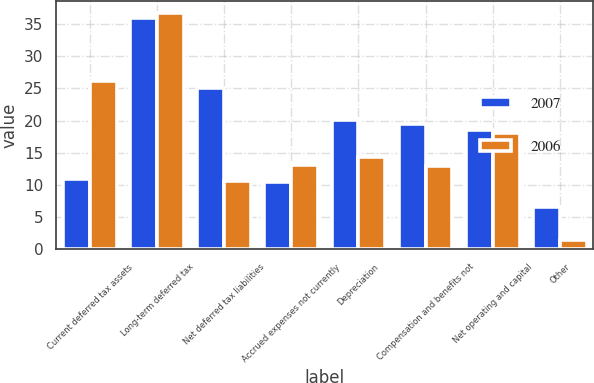<chart> <loc_0><loc_0><loc_500><loc_500><stacked_bar_chart><ecel><fcel>Current deferred tax assets<fcel>Long-term deferred tax<fcel>Net deferred tax liabilities<fcel>Accrued expenses not currently<fcel>Depreciation<fcel>Compensation and benefits not<fcel>Net operating and capital<fcel>Other<nl><fcel>2007<fcel>10.9<fcel>36<fcel>25.1<fcel>10.4<fcel>20.1<fcel>19.5<fcel>18.6<fcel>6.6<nl><fcel>2006<fcel>26.1<fcel>36.7<fcel>10.6<fcel>13.1<fcel>14.4<fcel>12.9<fcel>18.1<fcel>1.4<nl></chart> 